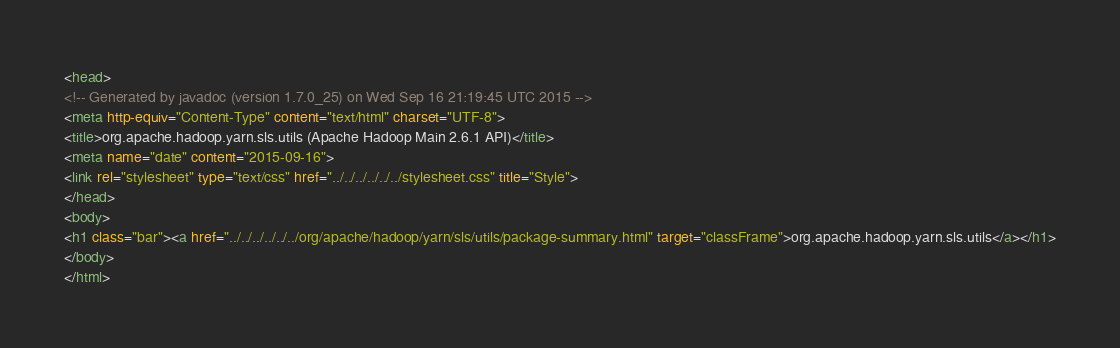Convert code to text. <code><loc_0><loc_0><loc_500><loc_500><_HTML_><head>
<!-- Generated by javadoc (version 1.7.0_25) on Wed Sep 16 21:19:45 UTC 2015 -->
<meta http-equiv="Content-Type" content="text/html" charset="UTF-8">
<title>org.apache.hadoop.yarn.sls.utils (Apache Hadoop Main 2.6.1 API)</title>
<meta name="date" content="2015-09-16">
<link rel="stylesheet" type="text/css" href="../../../../../../stylesheet.css" title="Style">
</head>
<body>
<h1 class="bar"><a href="../../../../../../org/apache/hadoop/yarn/sls/utils/package-summary.html" target="classFrame">org.apache.hadoop.yarn.sls.utils</a></h1>
</body>
</html>
</code> 